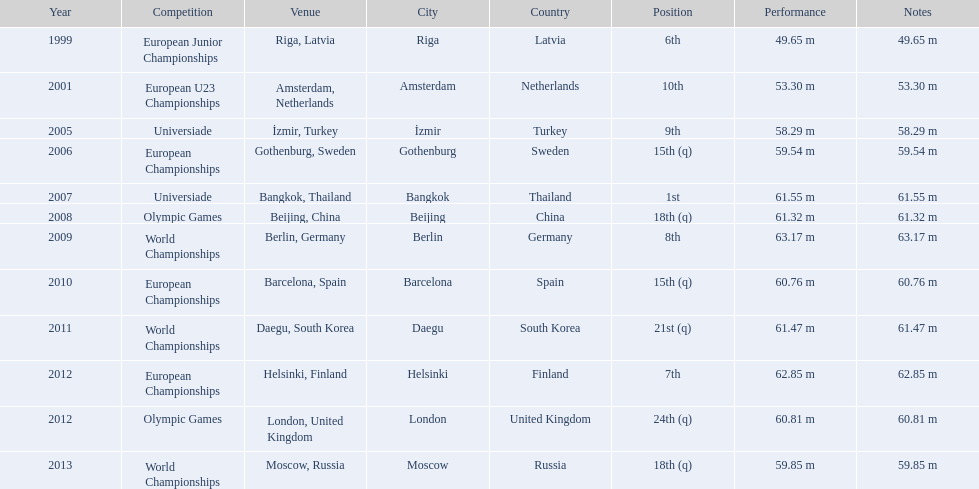What european junior championships? 6th. Parse the full table. {'header': ['Year', 'Competition', 'Venue', 'City', 'Country', 'Position', 'Performance', 'Notes'], 'rows': [['1999', 'European Junior Championships', 'Riga, Latvia', 'Riga', 'Latvia', '6th', '49.65 m', '49.65 m'], ['2001', 'European U23 Championships', 'Amsterdam, Netherlands', 'Amsterdam', 'Netherlands', '10th', '53.30 m', '53.30 m'], ['2005', 'Universiade', 'İzmir, Turkey', 'İzmir', 'Turkey', '9th', '58.29 m', '58.29 m'], ['2006', 'European Championships', 'Gothenburg, Sweden', 'Gothenburg', 'Sweden', '15th (q)', '59.54 m', '59.54 m'], ['2007', 'Universiade', 'Bangkok, Thailand', 'Bangkok', 'Thailand', '1st', '61.55 m', '61.55 m'], ['2008', 'Olympic Games', 'Beijing, China', 'Beijing', 'China', '18th (q)', '61.32 m', '61.32 m'], ['2009', 'World Championships', 'Berlin, Germany', 'Berlin', 'Germany', '8th', '63.17 m', '63.17 m'], ['2010', 'European Championships', 'Barcelona, Spain', 'Barcelona', 'Spain', '15th (q)', '60.76 m', '60.76 m'], ['2011', 'World Championships', 'Daegu, South Korea', 'Daegu', 'South Korea', '21st (q)', '61.47 m', '61.47 m'], ['2012', 'European Championships', 'Helsinki, Finland', 'Helsinki', 'Finland', '7th', '62.85 m', '62.85 m'], ['2012', 'Olympic Games', 'London, United Kingdom', 'London', 'United Kingdom', '24th (q)', '60.81 m', '60.81 m'], ['2013', 'World Championships', 'Moscow, Russia', 'Moscow', 'Russia', '18th (q)', '59.85 m', '59.85 m']]} What waseuropean junior championships best result? 63.17 m. 